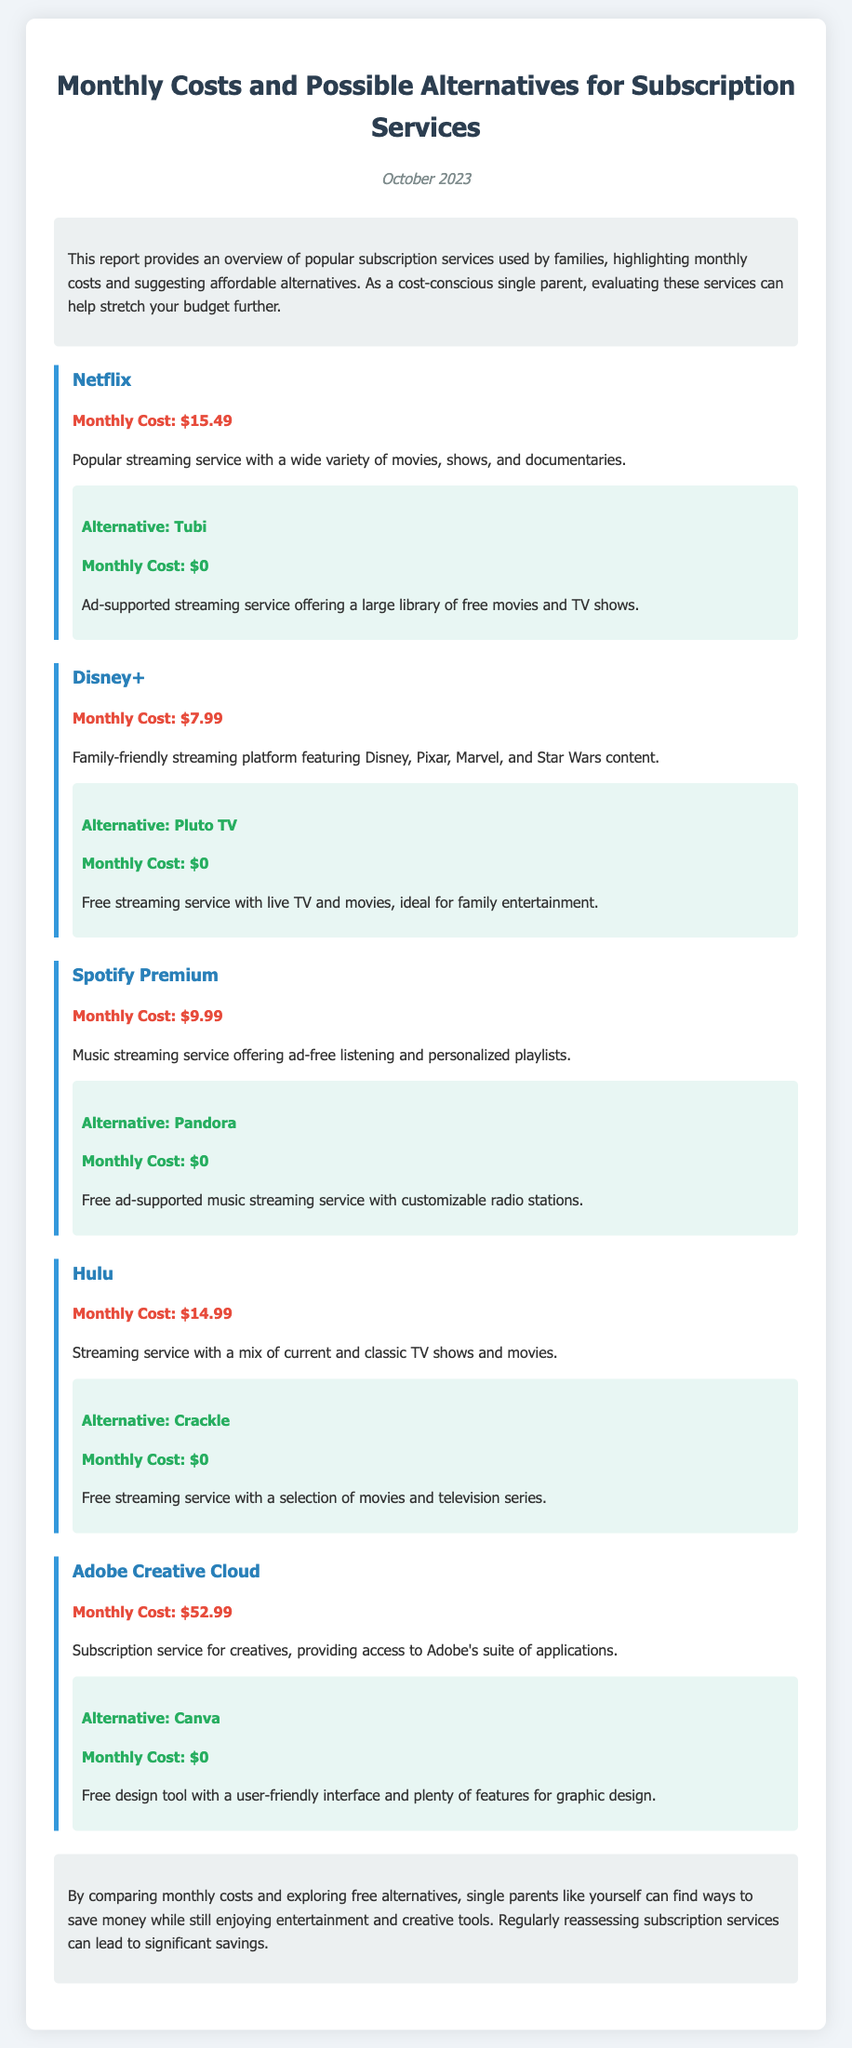What is the monthly cost of Netflix? The monthly cost of Netflix is listed in the report.
Answer: $15.49 What is the alternative to Disney+? The report mentions the alternative service available for Disney+.
Answer: Pluto TV How much can I save by choosing the alternative to Spotify Premium? The alternative service to Spotify Premium costs $0, while the original service costs $9.99.
Answer: $9.99 Which streaming service is noted for family-friendly content? The report describes Disney+ as a family-friendly platform.
Answer: Disney+ What is the total monthly cost of Hulu and Adobe Creative Cloud combined? The costs of Hulu and Adobe Creative Cloud are added together for this total calculation: $14.99 + $52.99.
Answer: $67.98 What is a common feature of the alternatives suggested in the report? All alternatives suggested in the report provide access to services for no monthly cost.
Answer: Free What date is the summary report issued? The date of issue for the document is specified at the top of the report.
Answer: October 2023 What type of services does the report provide an overview of? The report focuses on subscription services.
Answer: Subscription Services 